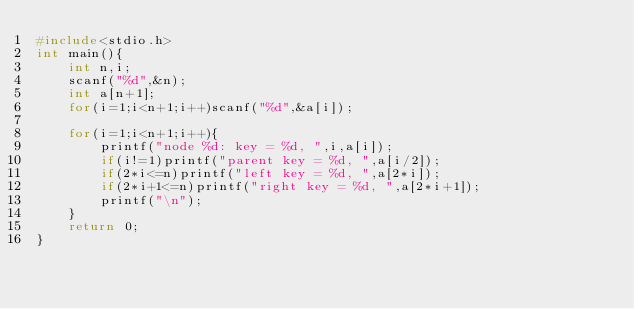<code> <loc_0><loc_0><loc_500><loc_500><_C_>#include<stdio.h>
int main(){
    int n,i;
    scanf("%d",&n);
    int a[n+1];
    for(i=1;i<n+1;i++)scanf("%d",&a[i]);

    for(i=1;i<n+1;i++){
        printf("node %d: key = %d, ",i,a[i]);
        if(i!=1)printf("parent key = %d, ",a[i/2]);
        if(2*i<=n)printf("left key = %d, ",a[2*i]);
        if(2*i+1<=n)printf("right key = %d, ",a[2*i+1]);
        printf("\n");
    }
    return 0;
}

</code> 